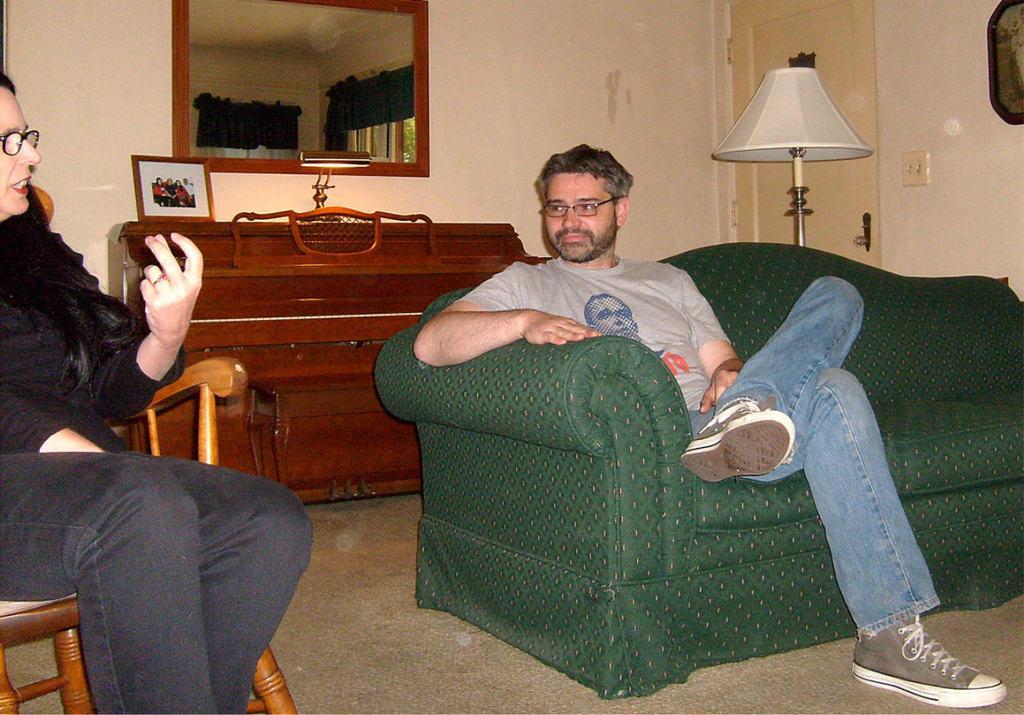Describe this image in one or two sentences. The person in the right is sitting in a green sofa and there is another person sitting in a chair beside him and there is a mirror and a wooden table behind them. 